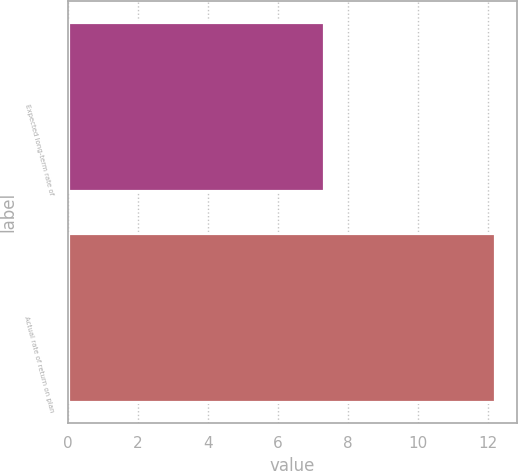Convert chart. <chart><loc_0><loc_0><loc_500><loc_500><bar_chart><fcel>Expected long-term rate of<fcel>Actual rate of return on plan<nl><fcel>7.32<fcel>12.2<nl></chart> 